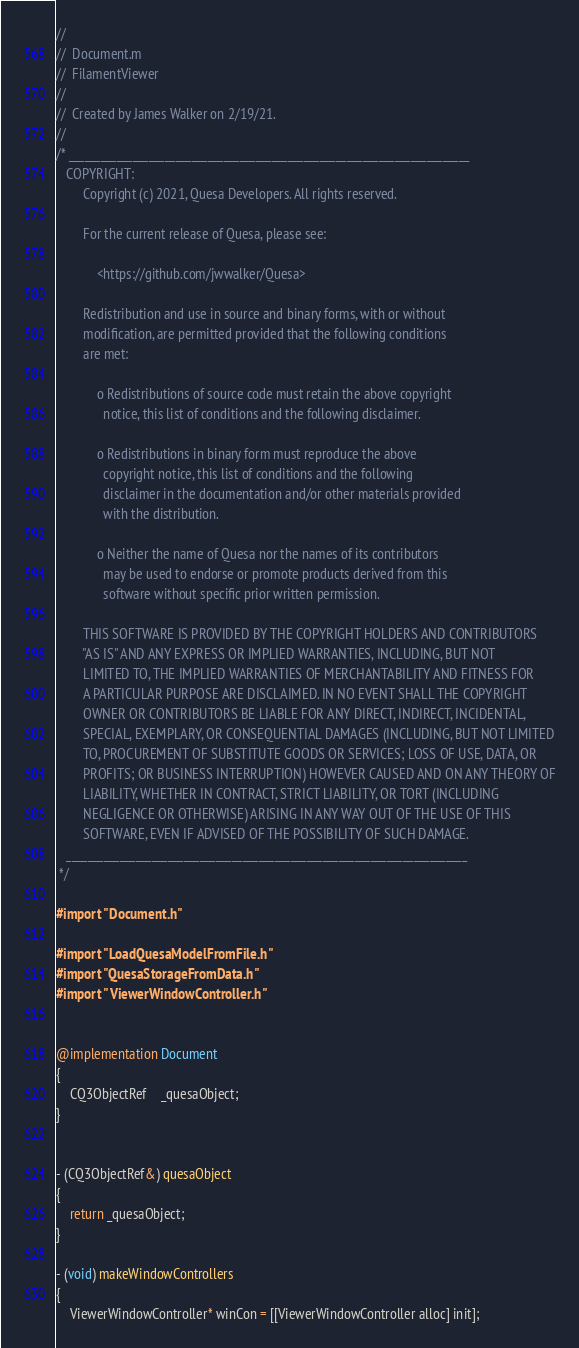<code> <loc_0><loc_0><loc_500><loc_500><_ObjectiveC_>//
//  Document.m
//  FilamentViewer
//
//  Created by James Walker on 2/19/21.
//
/* ___________________________________________________________________________
   COPYRIGHT:
        Copyright (c) 2021, Quesa Developers. All rights reserved.

        For the current release of Quesa, please see:

            <https://github.com/jwwalker/Quesa>
        
        Redistribution and use in source and binary forms, with or without
        modification, are permitted provided that the following conditions
        are met:
        
            o Redistributions of source code must retain the above copyright
              notice, this list of conditions and the following disclaimer.
        
            o Redistributions in binary form must reproduce the above
              copyright notice, this list of conditions and the following
              disclaimer in the documentation and/or other materials provided
              with the distribution.
        
            o Neither the name of Quesa nor the names of its contributors
              may be used to endorse or promote products derived from this
              software without specific prior written permission.
        
        THIS SOFTWARE IS PROVIDED BY THE COPYRIGHT HOLDERS AND CONTRIBUTORS
        "AS IS" AND ANY EXPRESS OR IMPLIED WARRANTIES, INCLUDING, BUT NOT
        LIMITED TO, THE IMPLIED WARRANTIES OF MERCHANTABILITY AND FITNESS FOR
        A PARTICULAR PURPOSE ARE DISCLAIMED. IN NO EVENT SHALL THE COPYRIGHT
        OWNER OR CONTRIBUTORS BE LIABLE FOR ANY DIRECT, INDIRECT, INCIDENTAL,
        SPECIAL, EXEMPLARY, OR CONSEQUENTIAL DAMAGES (INCLUDING, BUT NOT LIMITED
        TO, PROCUREMENT OF SUBSTITUTE GOODS OR SERVICES; LOSS OF USE, DATA, OR
        PROFITS; OR BUSINESS INTERRUPTION) HOWEVER CAUSED AND ON ANY THEORY OF
        LIABILITY, WHETHER IN CONTRACT, STRICT LIABILITY, OR TORT (INCLUDING
        NEGLIGENCE OR OTHERWISE) ARISING IN ANY WAY OUT OF THE USE OF THIS
        SOFTWARE, EVEN IF ADVISED OF THE POSSIBILITY OF SUCH DAMAGE.
   ___________________________________________________________________________
 */

#import "Document.h"

#import "LoadQuesaModelFromFile.h"
#import "QuesaStorageFromData.h"
#import "ViewerWindowController.h"


@implementation Document
{
	CQ3ObjectRef	_quesaObject;
}


- (CQ3ObjectRef&) quesaObject
{
	return _quesaObject;
}

- (void) makeWindowControllers
{
	ViewerWindowController* winCon = [[ViewerWindowController alloc] init];</code> 